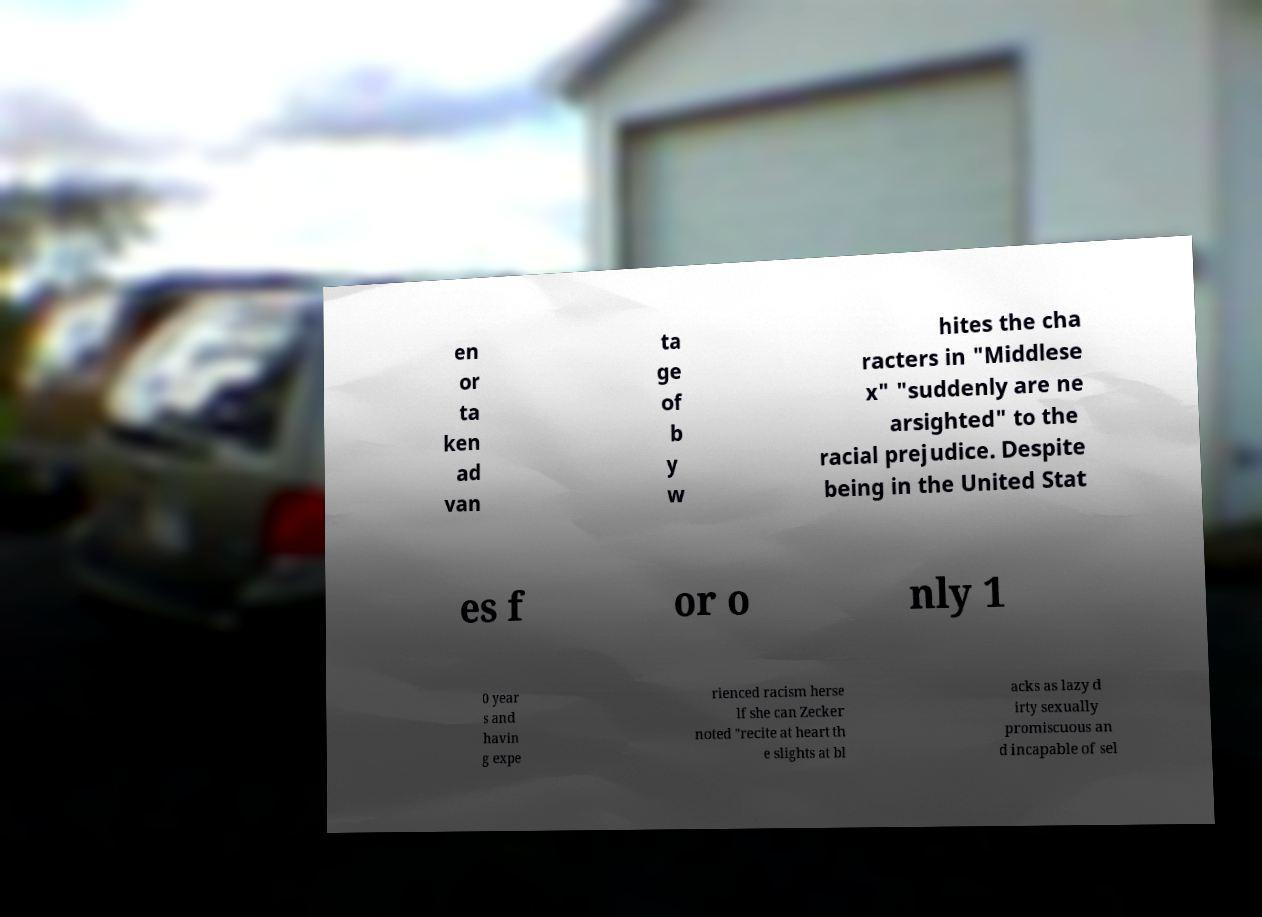Can you read and provide the text displayed in the image?This photo seems to have some interesting text. Can you extract and type it out for me? en or ta ken ad van ta ge of b y w hites the cha racters in "Middlese x" "suddenly are ne arsighted" to the racial prejudice. Despite being in the United Stat es f or o nly 1 0 year s and havin g expe rienced racism herse lf she can Zecker noted "recite at heart th e slights at bl acks as lazy d irty sexually promiscuous an d incapable of sel 